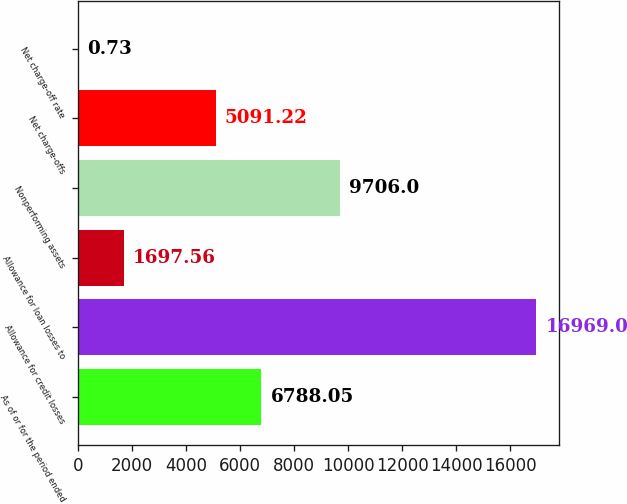<chart> <loc_0><loc_0><loc_500><loc_500><bar_chart><fcel>As of or for the period ended<fcel>Allowance for credit losses<fcel>Allowance for loan losses to<fcel>Nonperforming assets<fcel>Net charge-offs<fcel>Net charge-off rate<nl><fcel>6788.05<fcel>16969<fcel>1697.56<fcel>9706<fcel>5091.22<fcel>0.73<nl></chart> 